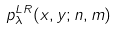Convert formula to latex. <formula><loc_0><loc_0><loc_500><loc_500>p ^ { L R } _ { \lambda } ( x , y ; { n } , { m } )</formula> 